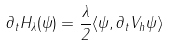Convert formula to latex. <formula><loc_0><loc_0><loc_500><loc_500>\partial _ { t } H _ { \lambda } ( \psi ) = \frac { \lambda } { 2 } \langle \psi , \partial _ { t } V _ { h } \psi \rangle</formula> 